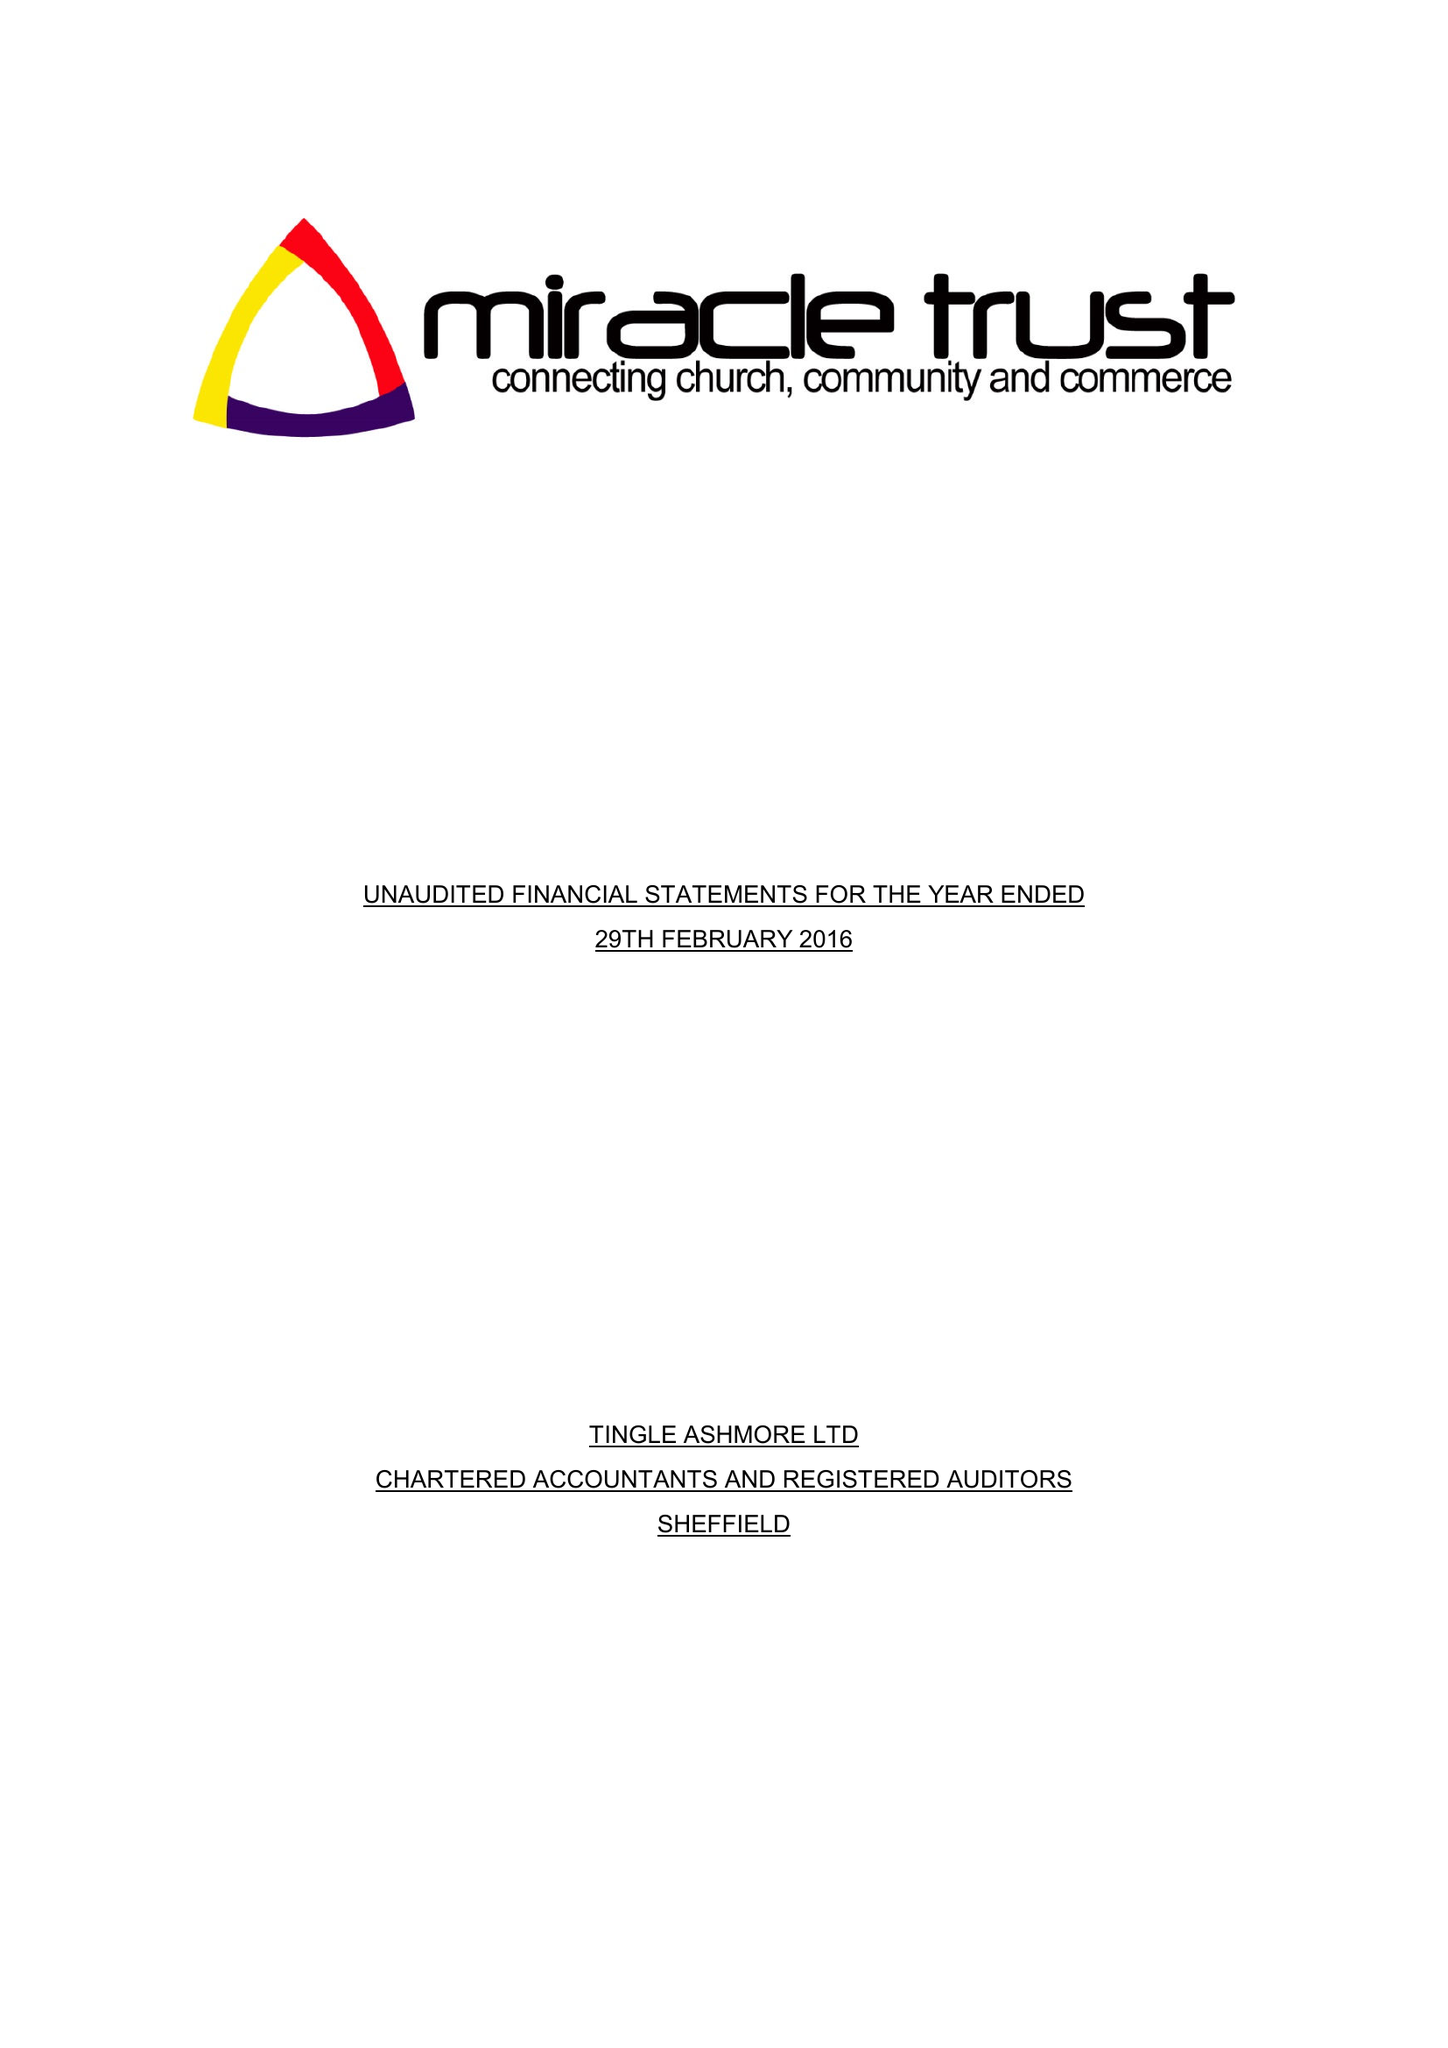What is the value for the spending_annually_in_british_pounds?
Answer the question using a single word or phrase. 98995.00 